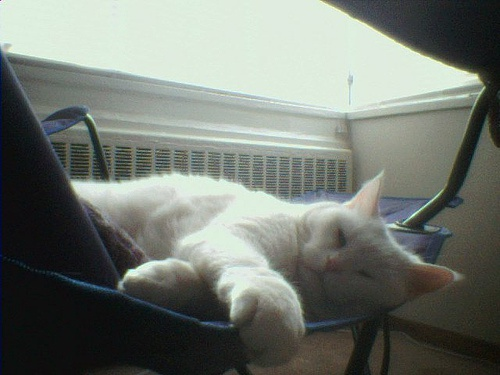Describe the objects in this image and their specific colors. I can see chair in gray, black, and blue tones and cat in gray, beige, black, and darkgray tones in this image. 